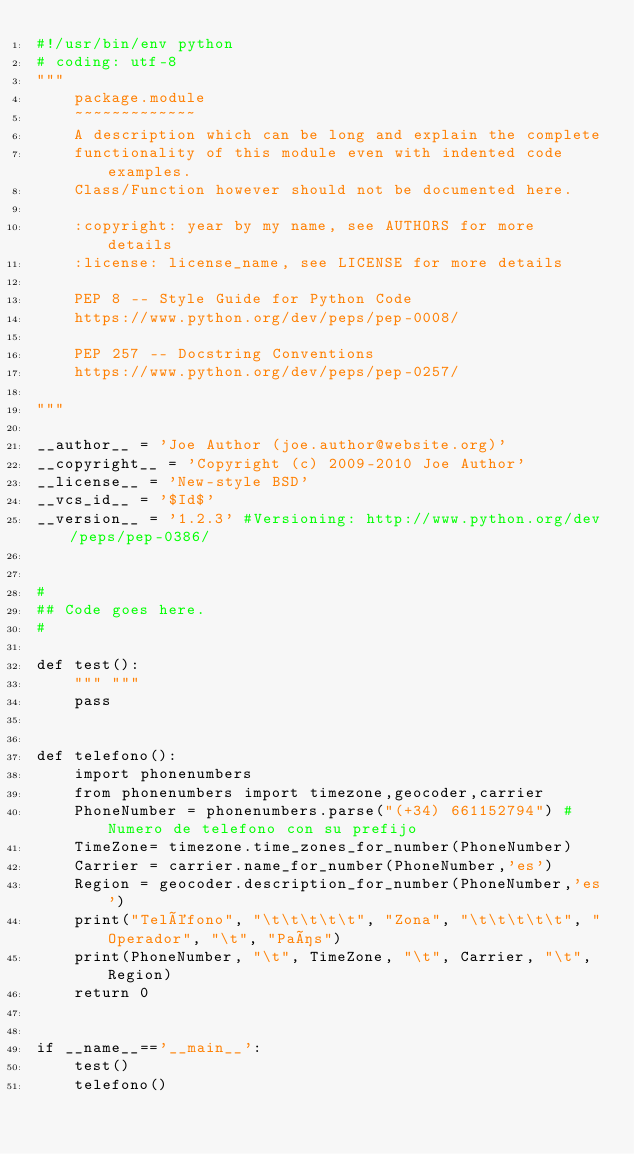Convert code to text. <code><loc_0><loc_0><loc_500><loc_500><_Python_>#!/usr/bin/env python
# coding: utf-8
"""
    package.module
    ~~~~~~~~~~~~~
    A description which can be long and explain the complete
    functionality of this module even with indented code examples.
    Class/Function however should not be documented here.

    :copyright: year by my name, see AUTHORS for more details
    :license: license_name, see LICENSE for more details

    PEP 8 -- Style Guide for Python Code
    https://www.python.org/dev/peps/pep-0008/

    PEP 257 -- Docstring Conventions
    https://www.python.org/dev/peps/pep-0257/

"""

__author__ = 'Joe Author (joe.author@website.org)'
__copyright__ = 'Copyright (c) 2009-2010 Joe Author'
__license__ = 'New-style BSD'
__vcs_id__ = '$Id$'
__version__ = '1.2.3' #Versioning: http://www.python.org/dev/peps/pep-0386/


#
## Code goes here.
#

def test():
    """ """
    pass


def telefono():
    import phonenumbers
    from phonenumbers import timezone,geocoder,carrier
    PhoneNumber = phonenumbers.parse("(+34) 661152794") #Numero de telefono con su prefijo
    TimeZone= timezone.time_zones_for_number(PhoneNumber)
    Carrier = carrier.name_for_number(PhoneNumber,'es')
    Region = geocoder.description_for_number(PhoneNumber,'es')
    print("Teléfono", "\t\t\t\t\t", "Zona", "\t\t\t\t\t", "Operador", "\t", "País")
    print(PhoneNumber, "\t", TimeZone, "\t", Carrier, "\t", Region)
    return 0


if __name__=='__main__':
    test()
    telefono()

</code> 